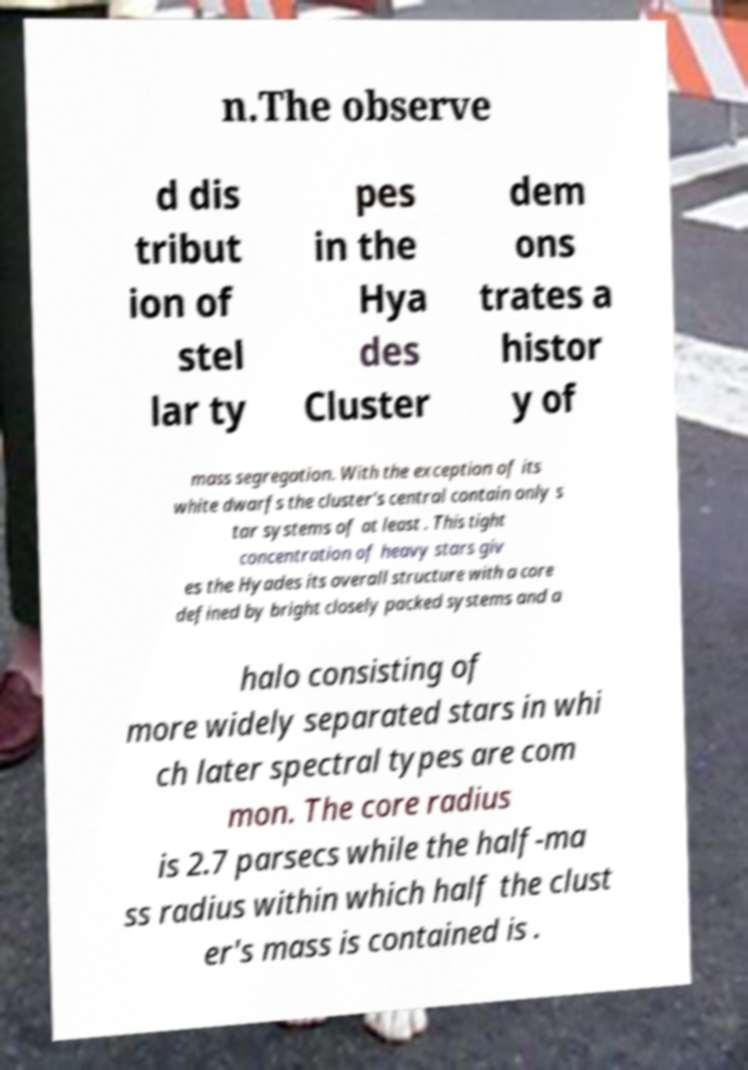For documentation purposes, I need the text within this image transcribed. Could you provide that? n.The observe d dis tribut ion of stel lar ty pes in the Hya des Cluster dem ons trates a histor y of mass segregation. With the exception of its white dwarfs the cluster's central contain only s tar systems of at least . This tight concentration of heavy stars giv es the Hyades its overall structure with a core defined by bright closely packed systems and a halo consisting of more widely separated stars in whi ch later spectral types are com mon. The core radius is 2.7 parsecs while the half-ma ss radius within which half the clust er's mass is contained is . 